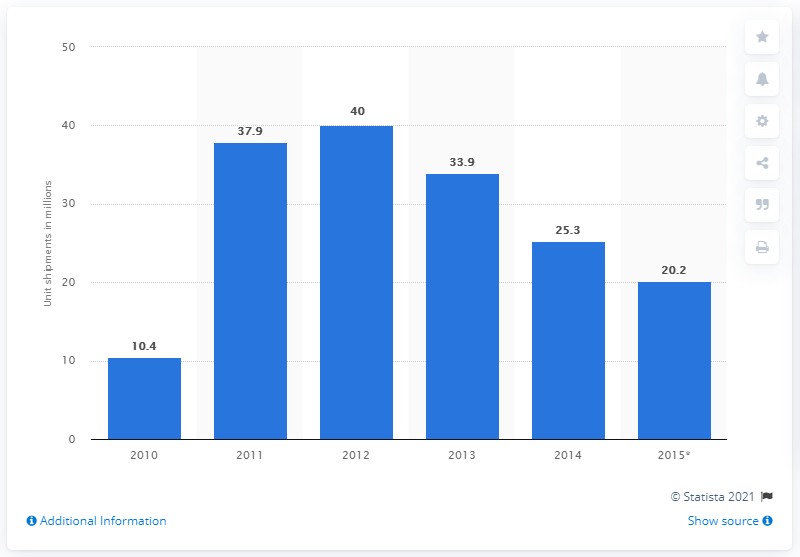Draw attention to some important aspects in this diagram. In 2013, a total of 33.9 units of e-Readers were shipped worldwide. 